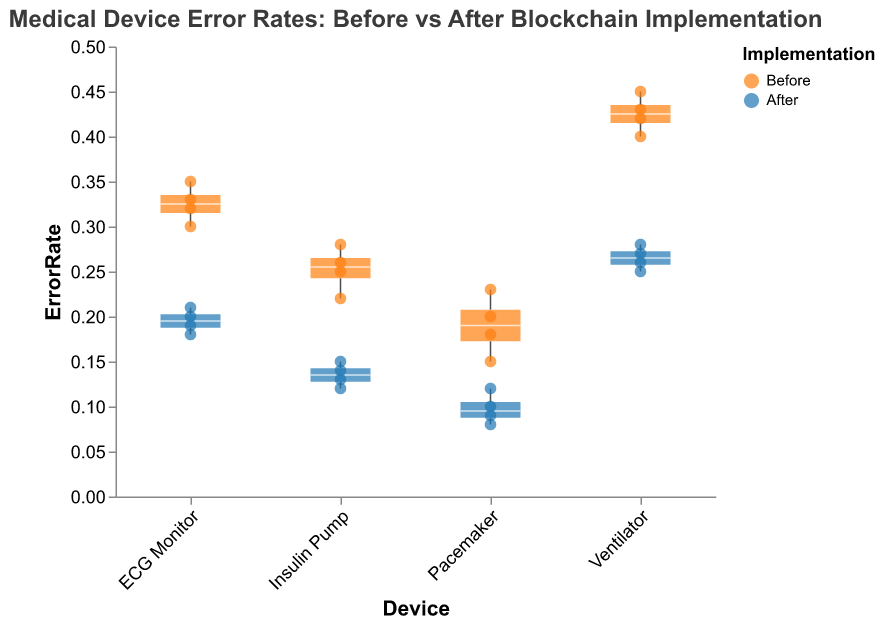What is the title of the figure? The title is located at the top of the figure and provides a clear description.
Answer: Medical Device Error Rates: Before vs After Blockchain Implementation Which color represents the "After" implementation? By inspecting the legend, we observe that the blue color represents the "After" implementation.
Answer: Blue How many individual data points are there for the ECG Monitor before blockchain implementation? By counting the scatter points for the "ECG Monitor" in the "Before" category, we can determine the number of data points.
Answer: 4 What is the lowest error rate for the Ventilator after blockchain implementation? The lowest error rate is the smallest y-value on the scatter points for the Ventilator in the "After" category.
Answer: 0.25 What is the upper quartile of the error rate for Insulin Pump after blockchain implementation? The upper quartile (75th percentile) can be identified from the top edge of the box in the "After" category for the Insulin Pump.
Answer: 0.15 Compare the median error rate of the Pacemaker before and after blockchain implementation. Which is higher? The medians are represented by the line inside each box. We compare the position of these lines in the "Before" and "After" categories for the Pacemaker.
Answer: Before What is the range of the error rates for the Ventilator before blockchain implementation? The range is the difference between the maximum and minimum error rates, which can be identified by referring to the extent of the scatter points for the Ventilator in the "Before" category.
Answer: 0.45 - 0.40 Which medical device shows the greatest improvement in error rates after blockchain implementation? To determine this, we compare the shifts in median error rates before and after implementation for each device. The device with the largest decrease indicates the greatest improvement. Ventilator has the most notable reduction.
Answer: Ventilator Looking at the box plots, which device has the highest variability in error rates after blockchain implementation? Variability can be assessed by the height of the boxes in the "After" category. The taller the box, the higher the variability.
Answer: ECG Monitor 